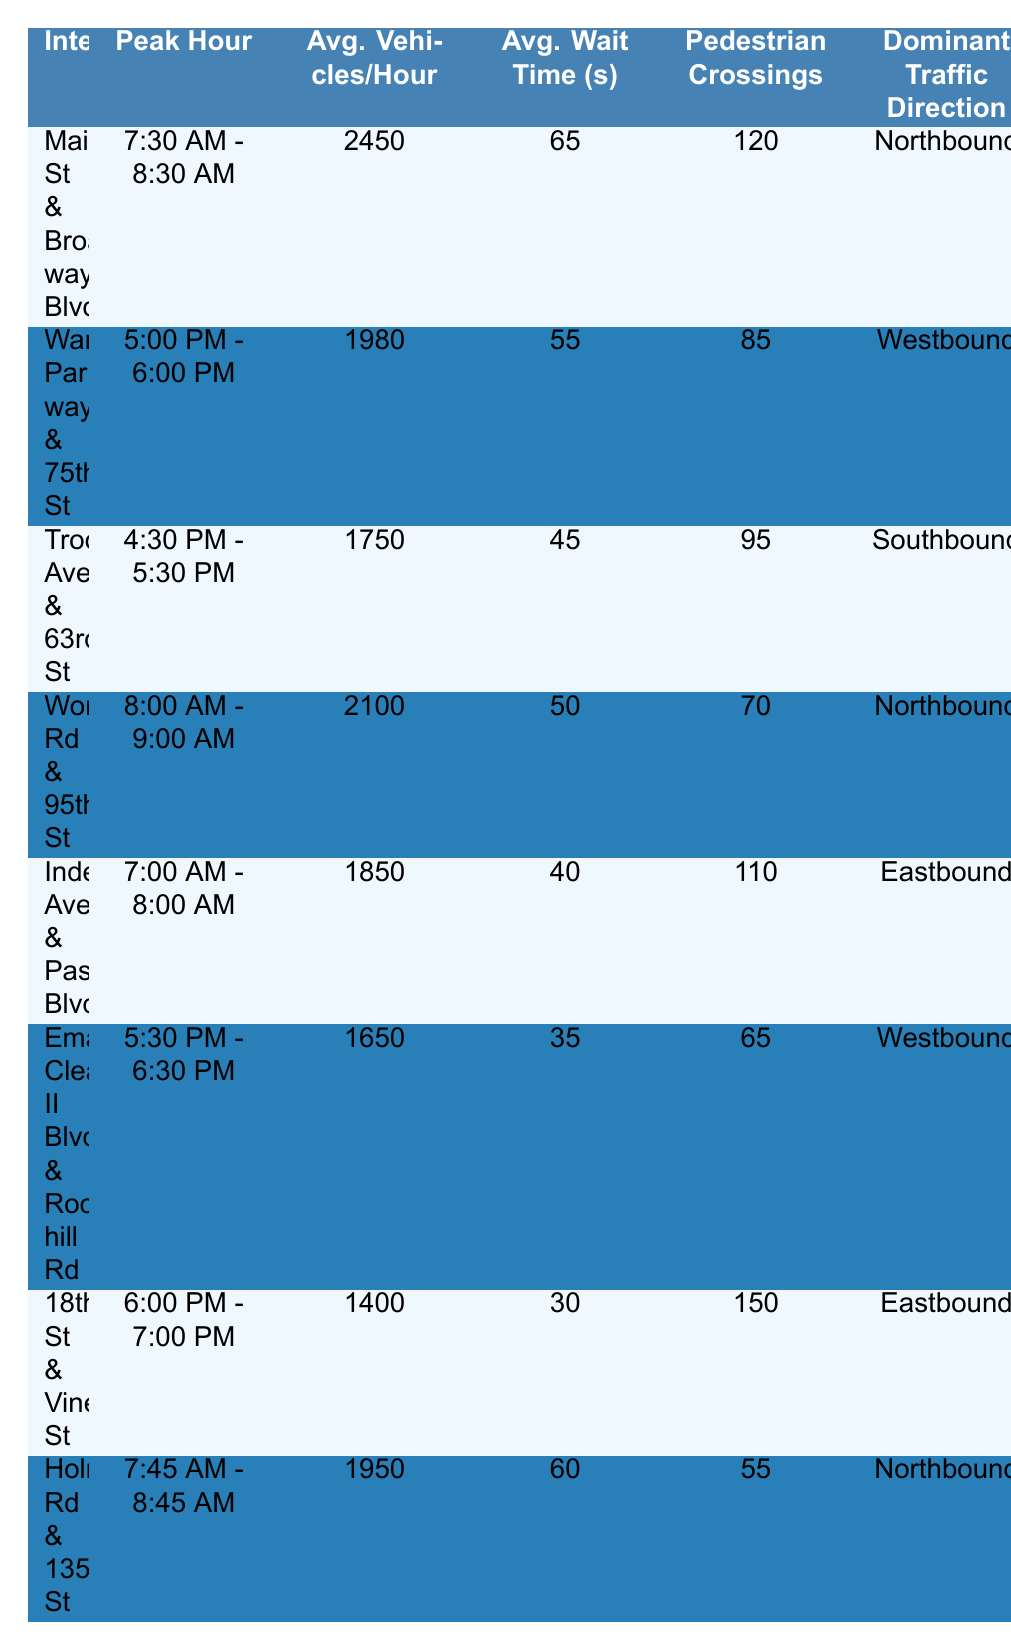What is the average number of vehicles per hour at the intersection of Main St & Broadway Blvd? The table shows that the average vehicles per hour at Main St & Broadway Blvd is listed as 2450.
Answer: 2450 During which peak hour does Ward Parkway & 75th St see the highest average wait time? The table shows the average wait time for Ward Parkway & 75th St is 55 seconds. This is the peak hour from 5:00 PM to 6:00 PM according to the data.
Answer: 5:00 PM - 6:00 PM Which intersection has the highest accident rate? By comparing the accident rates listed in the table: Main St & Broadway Blvd (1.2), Ward Parkway & 75th St (0.9), Troost Ave & 63rd St (1.5), and others, Troost Ave & 63rd St has the highest accident rate at 1.5 per 1000 vehicles.
Answer: Troost Ave & 63rd St What is the total number of pedestrian crossings for both Main St & Broadway Blvd and Wornall Rd & 95th St combined? From the table, Main St & Broadway Blvd has 120 pedestrian crossings, and Wornall Rd & 95th St has 70 pedestrian crossings. Adding these gives 120 + 70 = 190 pedestrian crossings total.
Answer: 190 Is the dominant traffic direction at Holmes Rd & 135th St Northbound or Southbound? The table indicates that the dominant traffic direction at Holmes Rd & 135th St is Northbound.
Answer: Northbound What is the average wait time across all intersections listed? To find the average wait time, we sum the wait times: 65 + 55 + 45 + 50 + 40 + 35 + 30 + 60 = 380 seconds. There are 8 intersections, so average wait time = 380 / 8 = 47.5 seconds.
Answer: 47.5 seconds Which peak hour has the highest average vehicles per hour, and what is that number? Looking at the average vehicles per hour in the table, the peak hour 7:30 AM - 8:30 AM at Main St & Broadway Blvd has the highest number of 2450 vehicles.
Answer: 7:30 AM - 8:30 AM, 2450 vehicles Are there any intersections with fewer than 1500 average vehicles per hour? Analyzing the average vehicles per hour in the table, both Emanuel Cleaver II Blvd & Rockhill Rd (1650) and 18th St & Vine St (1400) are the only ones below 1500 vehicles per hour. Hence, 18th St & Vine St qualifies.
Answer: Yes Which intersection has the lowest average wait time? By checking the values, 18th St & Vine St has the lowest average wait time of 30 seconds among all intersections.
Answer: 18th St & Vine St If we consider only the evening peak hours, what is the average accident rate for the intersections listed? For evening peak hours (4:30 PM - 6:30 PM), we consider Troost Ave & 63rd St (1.5), Emanuel Cleaver II Blvd & Rockhill Rd (0.8), and 18th St & Vine St (0.7). The average accident rate is (1.5 + 0.8 + 0.7) / 3 = 1.0 per 1000 vehicles.
Answer: 1.0 per 1000 vehicles 